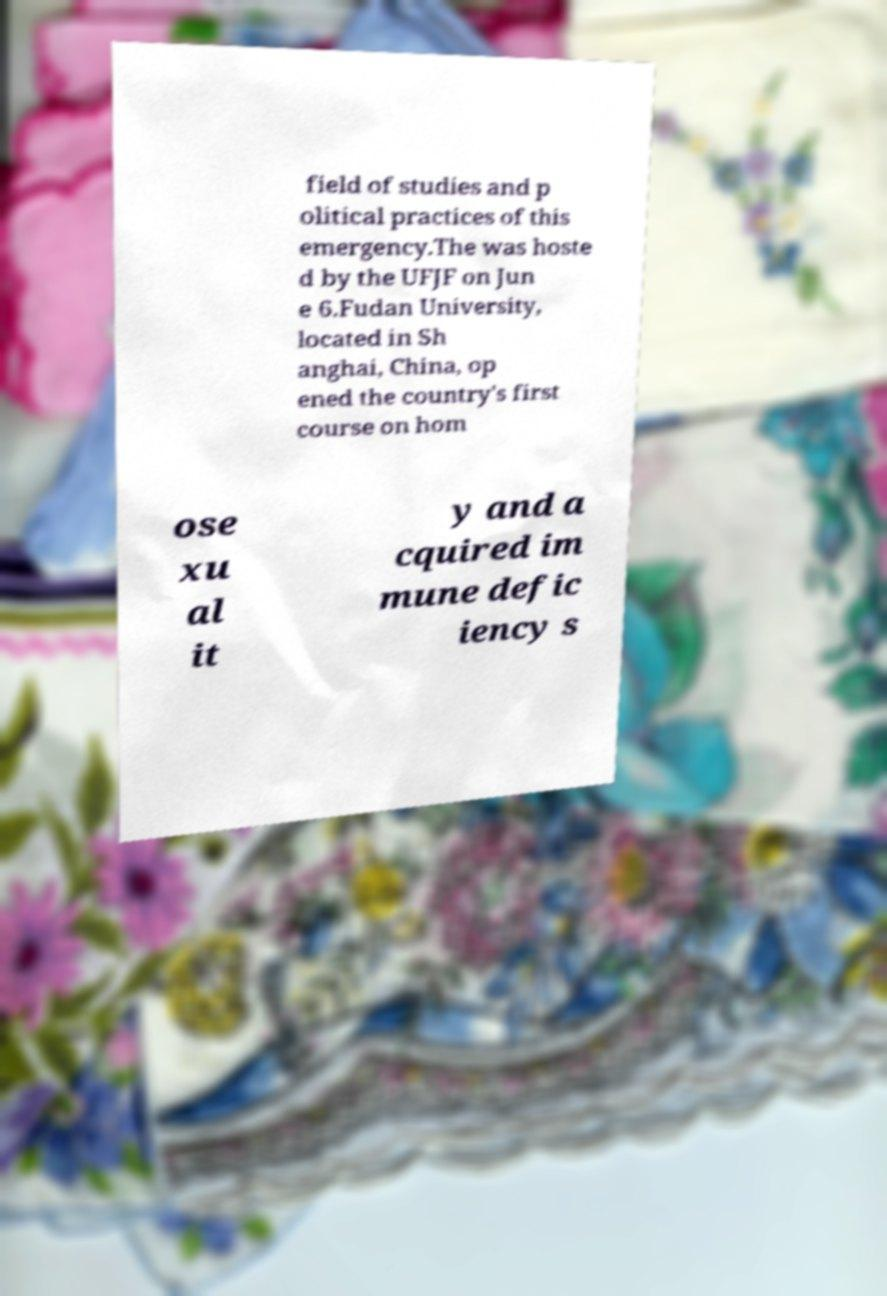There's text embedded in this image that I need extracted. Can you transcribe it verbatim? field of studies and p olitical practices of this emergency.The was hoste d by the UFJF on Jun e 6.Fudan University, located in Sh anghai, China, op ened the country's first course on hom ose xu al it y and a cquired im mune defic iency s 